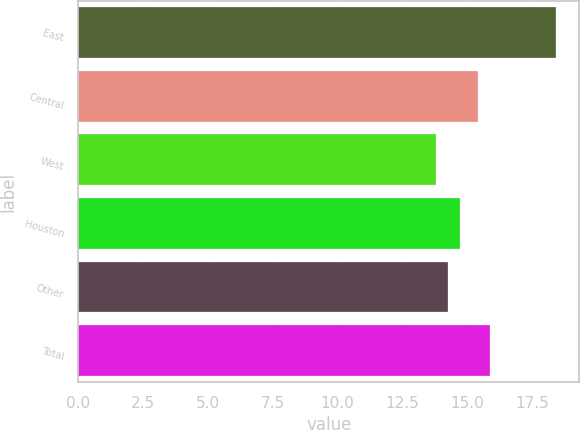Convert chart. <chart><loc_0><loc_0><loc_500><loc_500><bar_chart><fcel>East<fcel>Central<fcel>West<fcel>Houston<fcel>Other<fcel>Total<nl><fcel>18.4<fcel>15.4<fcel>13.8<fcel>14.72<fcel>14.26<fcel>15.86<nl></chart> 